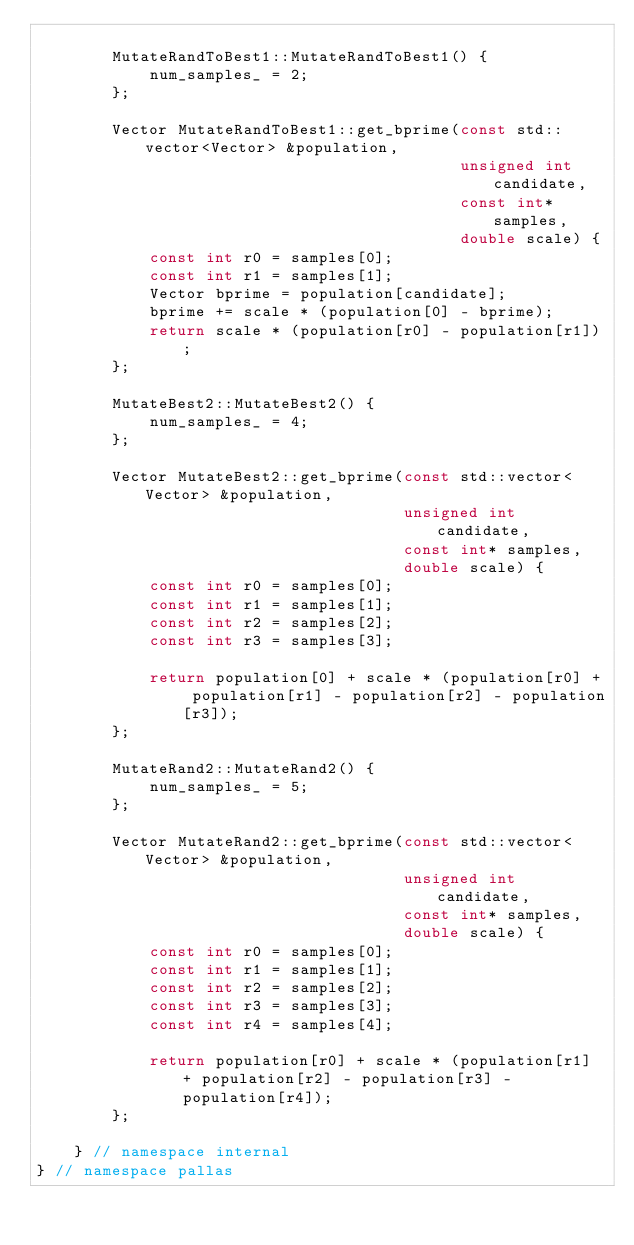<code> <loc_0><loc_0><loc_500><loc_500><_C++_>
        MutateRandToBest1::MutateRandToBest1() {
            num_samples_ = 2;
        };

        Vector MutateRandToBest1::get_bprime(const std::vector<Vector> &population,
                                             unsigned int candidate,
                                             const int* samples,
                                             double scale) {
            const int r0 = samples[0];
            const int r1 = samples[1];
            Vector bprime = population[candidate];
            bprime += scale * (population[0] - bprime);
            return scale * (population[r0] - population[r1]);
        };

        MutateBest2::MutateBest2() {
            num_samples_ = 4;
        };

        Vector MutateBest2::get_bprime(const std::vector<Vector> &population,
                                       unsigned int candidate,
                                       const int* samples,
                                       double scale) {
            const int r0 = samples[0];
            const int r1 = samples[1];
            const int r2 = samples[2];
            const int r3 = samples[3];

            return population[0] + scale * (population[r0] + population[r1] - population[r2] - population[r3]);
        };

        MutateRand2::MutateRand2() {
            num_samples_ = 5;
        };

        Vector MutateRand2::get_bprime(const std::vector<Vector> &population,
                                       unsigned int candidate,
                                       const int* samples,
                                       double scale) {
            const int r0 = samples[0];
            const int r1 = samples[1];
            const int r2 = samples[2];
            const int r3 = samples[3];
            const int r4 = samples[4];

            return population[r0] + scale * (population[r1] + population[r2] - population[r3] - population[r4]);
        };

    } // namespace internal
} // namespace pallas</code> 